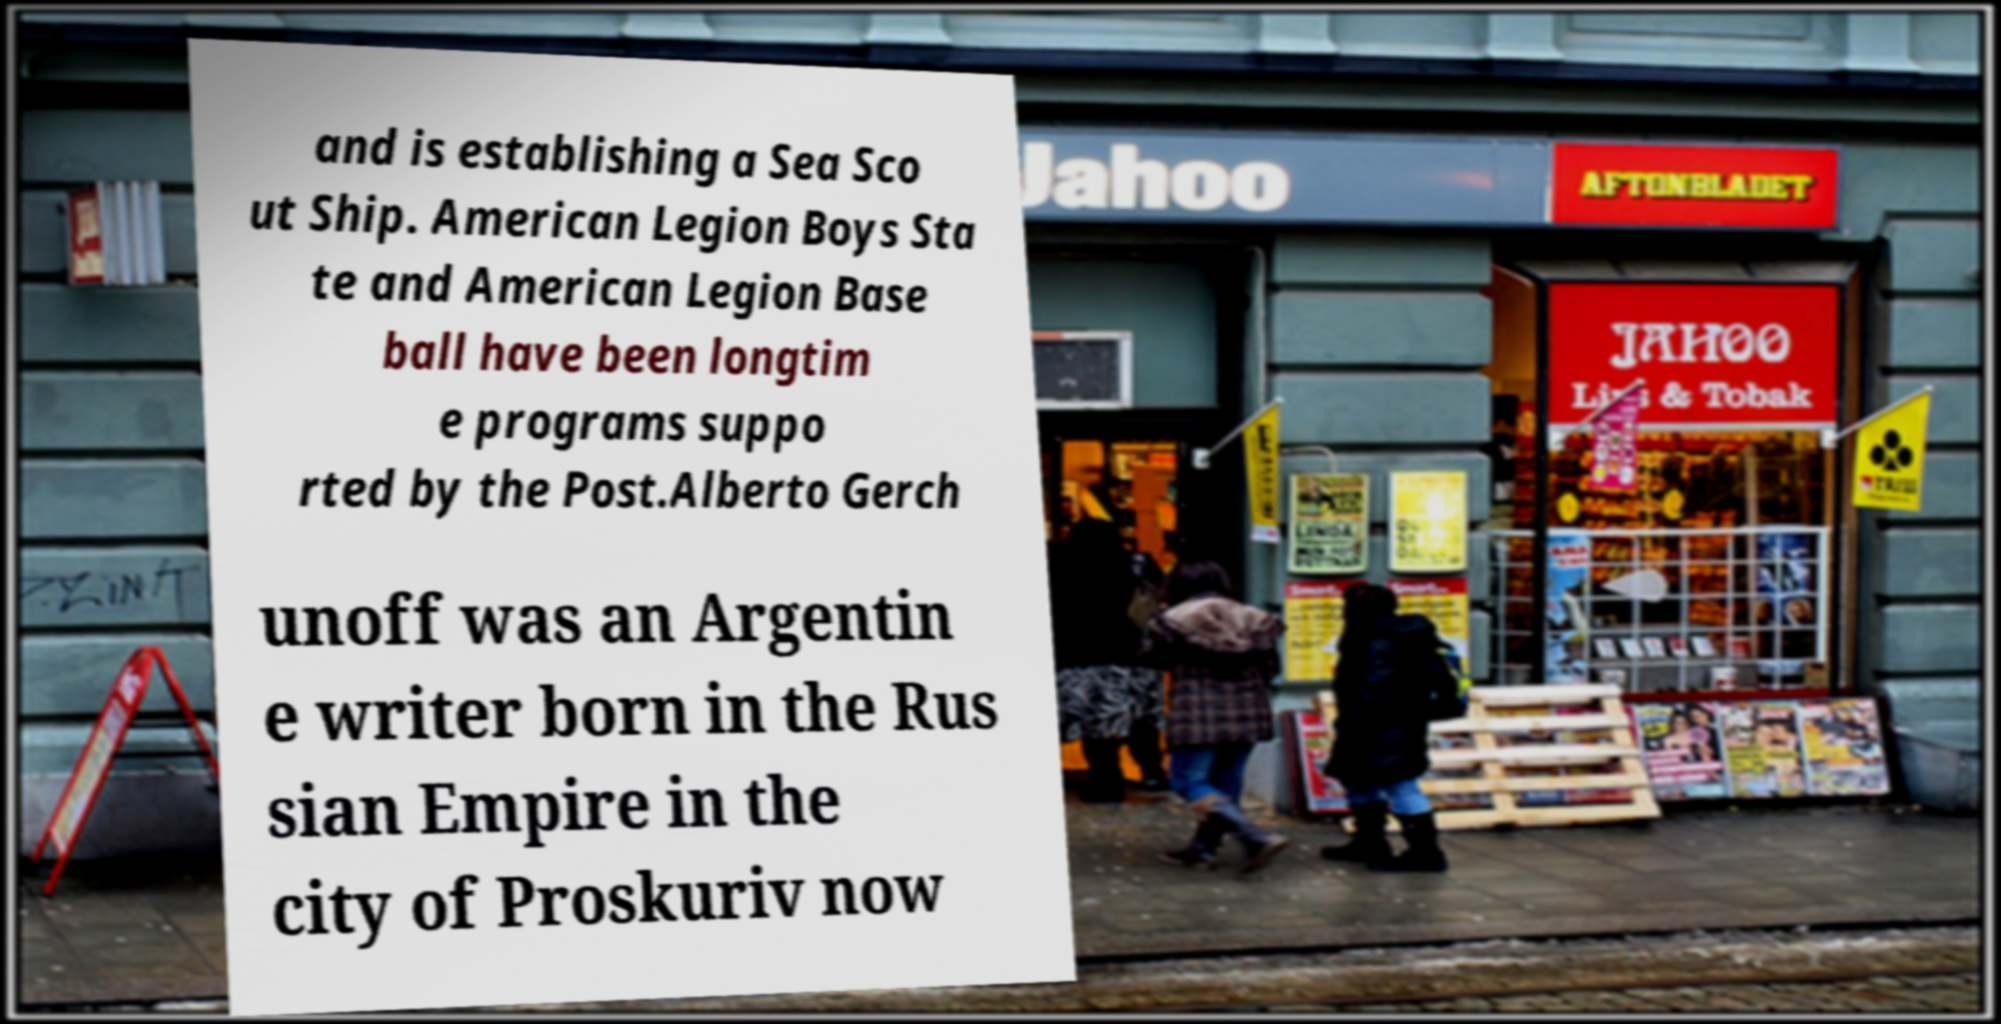Please read and relay the text visible in this image. What does it say? and is establishing a Sea Sco ut Ship. American Legion Boys Sta te and American Legion Base ball have been longtim e programs suppo rted by the Post.Alberto Gerch unoff was an Argentin e writer born in the Rus sian Empire in the city of Proskuriv now 